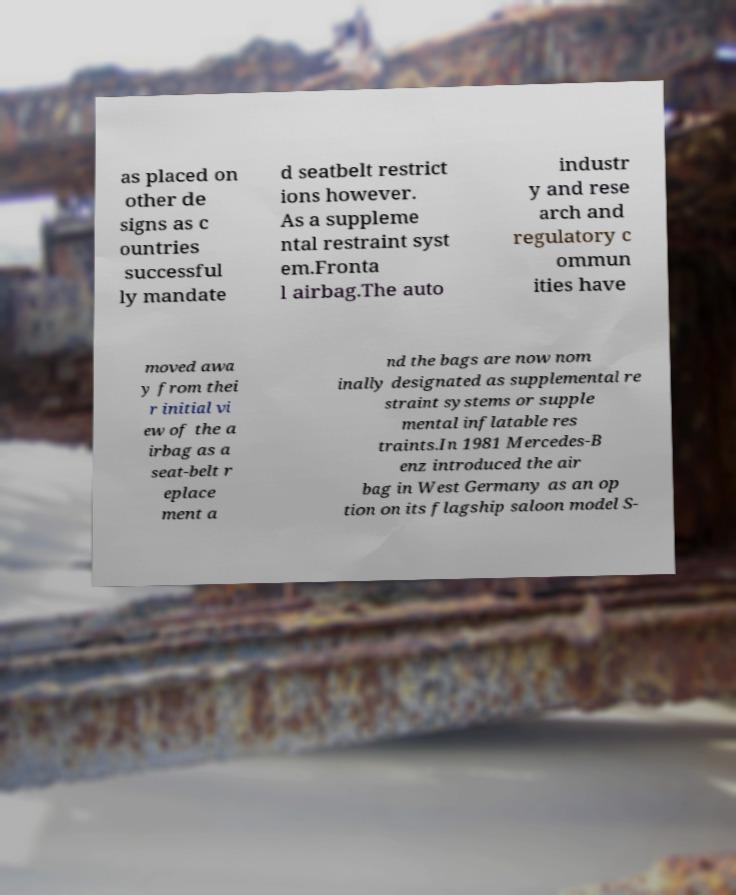Please identify and transcribe the text found in this image. as placed on other de signs as c ountries successful ly mandate d seatbelt restrict ions however. As a suppleme ntal restraint syst em.Fronta l airbag.The auto industr y and rese arch and regulatory c ommun ities have moved awa y from thei r initial vi ew of the a irbag as a seat-belt r eplace ment a nd the bags are now nom inally designated as supplemental re straint systems or supple mental inflatable res traints.In 1981 Mercedes-B enz introduced the air bag in West Germany as an op tion on its flagship saloon model S- 